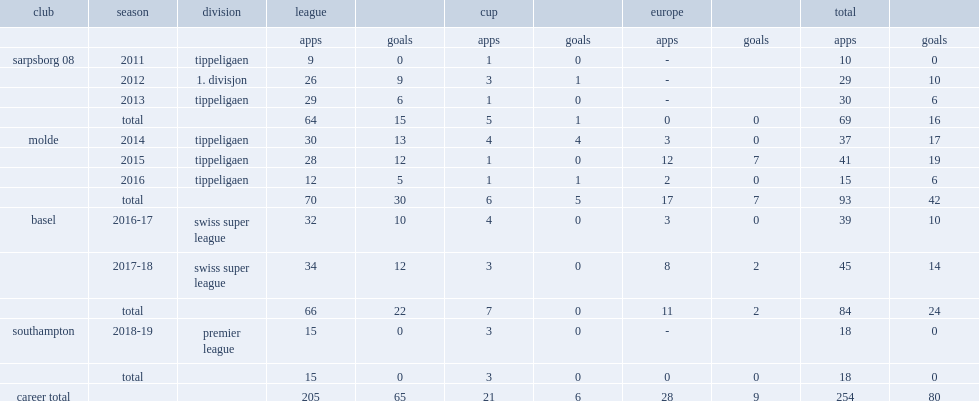Which club did mohamed elyounoussi play for in 2011? Sarpsborg 08. 